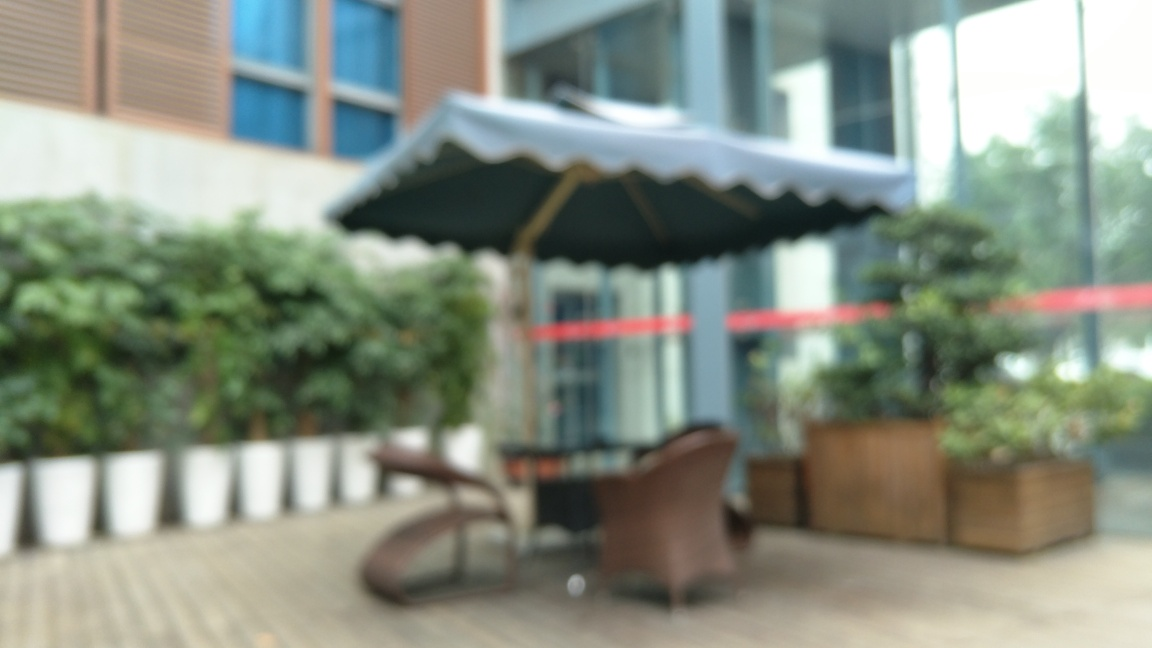Are the potted plants sharp? Due to the blurriness of the image, it's not possible to confirm the sharpness of the potted plants' details. The photo's focus does not allow for an assessment of the texture or edges of the leaves, which are typical indicators of sharpness in an image. 